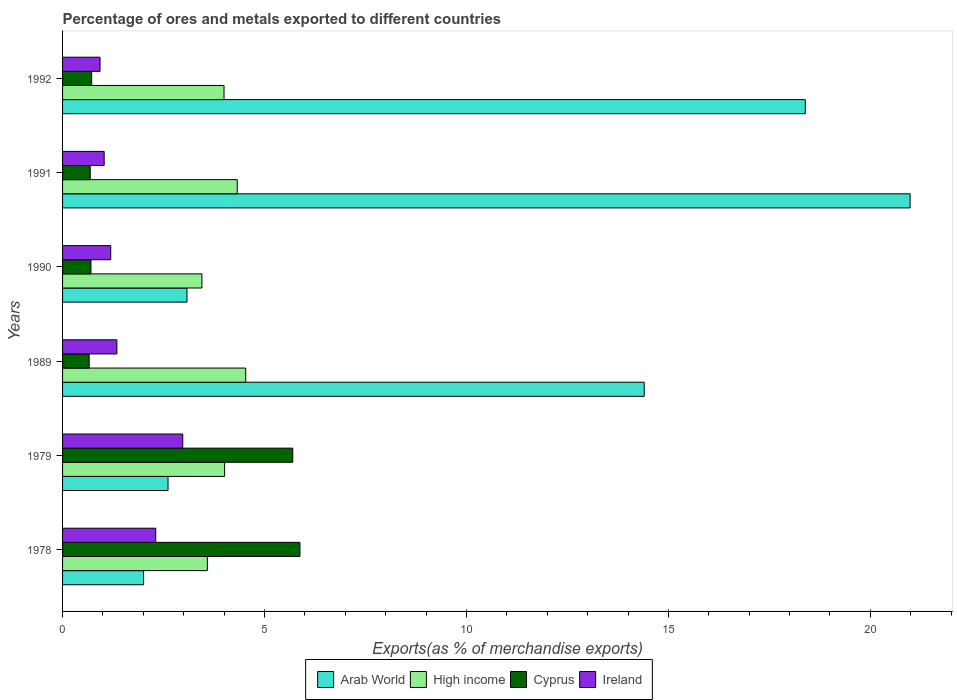How many different coloured bars are there?
Provide a succinct answer. 4. How many groups of bars are there?
Offer a very short reply. 6. Are the number of bars per tick equal to the number of legend labels?
Provide a succinct answer. Yes. In how many cases, is the number of bars for a given year not equal to the number of legend labels?
Offer a terse response. 0. What is the percentage of exports to different countries in Cyprus in 1992?
Provide a succinct answer. 0.72. Across all years, what is the maximum percentage of exports to different countries in High income?
Offer a terse response. 4.54. Across all years, what is the minimum percentage of exports to different countries in Cyprus?
Keep it short and to the point. 0.66. In which year was the percentage of exports to different countries in Cyprus maximum?
Ensure brevity in your answer.  1978. In which year was the percentage of exports to different countries in Arab World minimum?
Make the answer very short. 1978. What is the total percentage of exports to different countries in Ireland in the graph?
Your answer should be very brief. 9.78. What is the difference between the percentage of exports to different countries in Arab World in 1978 and that in 1992?
Keep it short and to the point. -16.38. What is the difference between the percentage of exports to different countries in High income in 1990 and the percentage of exports to different countries in Arab World in 1992?
Make the answer very short. -14.94. What is the average percentage of exports to different countries in High income per year?
Offer a terse response. 3.98. In the year 1979, what is the difference between the percentage of exports to different countries in Ireland and percentage of exports to different countries in Cyprus?
Your answer should be compact. -2.72. What is the ratio of the percentage of exports to different countries in Cyprus in 1979 to that in 1991?
Ensure brevity in your answer.  8.33. Is the percentage of exports to different countries in Ireland in 1979 less than that in 1990?
Your answer should be compact. No. Is the difference between the percentage of exports to different countries in Ireland in 1990 and 1992 greater than the difference between the percentage of exports to different countries in Cyprus in 1990 and 1992?
Your answer should be compact. Yes. What is the difference between the highest and the second highest percentage of exports to different countries in Arab World?
Provide a short and direct response. 2.6. What is the difference between the highest and the lowest percentage of exports to different countries in Arab World?
Give a very brief answer. 18.98. Is the sum of the percentage of exports to different countries in Ireland in 1979 and 1991 greater than the maximum percentage of exports to different countries in Arab World across all years?
Your answer should be very brief. No. What does the 3rd bar from the top in 1992 represents?
Make the answer very short. High income. What does the 4th bar from the bottom in 1992 represents?
Keep it short and to the point. Ireland. Are the values on the major ticks of X-axis written in scientific E-notation?
Offer a terse response. No. How are the legend labels stacked?
Provide a short and direct response. Horizontal. What is the title of the graph?
Keep it short and to the point. Percentage of ores and metals exported to different countries. What is the label or title of the X-axis?
Offer a terse response. Exports(as % of merchandise exports). What is the Exports(as % of merchandise exports) of Arab World in 1978?
Provide a short and direct response. 2.01. What is the Exports(as % of merchandise exports) in High income in 1978?
Offer a very short reply. 3.58. What is the Exports(as % of merchandise exports) of Cyprus in 1978?
Your answer should be compact. 5.88. What is the Exports(as % of merchandise exports) in Ireland in 1978?
Your answer should be very brief. 2.31. What is the Exports(as % of merchandise exports) in Arab World in 1979?
Your answer should be compact. 2.61. What is the Exports(as % of merchandise exports) of High income in 1979?
Give a very brief answer. 4.01. What is the Exports(as % of merchandise exports) in Cyprus in 1979?
Your response must be concise. 5.7. What is the Exports(as % of merchandise exports) of Ireland in 1979?
Make the answer very short. 2.98. What is the Exports(as % of merchandise exports) of Arab World in 1989?
Give a very brief answer. 14.4. What is the Exports(as % of merchandise exports) in High income in 1989?
Keep it short and to the point. 4.54. What is the Exports(as % of merchandise exports) in Cyprus in 1989?
Provide a short and direct response. 0.66. What is the Exports(as % of merchandise exports) in Ireland in 1989?
Your answer should be compact. 1.34. What is the Exports(as % of merchandise exports) in Arab World in 1990?
Make the answer very short. 3.08. What is the Exports(as % of merchandise exports) in High income in 1990?
Ensure brevity in your answer.  3.45. What is the Exports(as % of merchandise exports) of Cyprus in 1990?
Offer a very short reply. 0.7. What is the Exports(as % of merchandise exports) in Ireland in 1990?
Offer a very short reply. 1.19. What is the Exports(as % of merchandise exports) in Arab World in 1991?
Ensure brevity in your answer.  20.98. What is the Exports(as % of merchandise exports) in High income in 1991?
Ensure brevity in your answer.  4.32. What is the Exports(as % of merchandise exports) of Cyprus in 1991?
Keep it short and to the point. 0.68. What is the Exports(as % of merchandise exports) of Ireland in 1991?
Provide a short and direct response. 1.03. What is the Exports(as % of merchandise exports) in Arab World in 1992?
Give a very brief answer. 18.39. What is the Exports(as % of merchandise exports) of High income in 1992?
Your response must be concise. 4. What is the Exports(as % of merchandise exports) in Cyprus in 1992?
Offer a terse response. 0.72. What is the Exports(as % of merchandise exports) in Ireland in 1992?
Give a very brief answer. 0.93. Across all years, what is the maximum Exports(as % of merchandise exports) in Arab World?
Your response must be concise. 20.98. Across all years, what is the maximum Exports(as % of merchandise exports) in High income?
Keep it short and to the point. 4.54. Across all years, what is the maximum Exports(as % of merchandise exports) of Cyprus?
Your answer should be very brief. 5.88. Across all years, what is the maximum Exports(as % of merchandise exports) in Ireland?
Offer a very short reply. 2.98. Across all years, what is the minimum Exports(as % of merchandise exports) of Arab World?
Give a very brief answer. 2.01. Across all years, what is the minimum Exports(as % of merchandise exports) in High income?
Your answer should be compact. 3.45. Across all years, what is the minimum Exports(as % of merchandise exports) in Cyprus?
Ensure brevity in your answer.  0.66. Across all years, what is the minimum Exports(as % of merchandise exports) of Ireland?
Give a very brief answer. 0.93. What is the total Exports(as % of merchandise exports) in Arab World in the graph?
Provide a succinct answer. 61.47. What is the total Exports(as % of merchandise exports) of High income in the graph?
Offer a very short reply. 23.91. What is the total Exports(as % of merchandise exports) of Cyprus in the graph?
Provide a succinct answer. 14.34. What is the total Exports(as % of merchandise exports) in Ireland in the graph?
Offer a very short reply. 9.78. What is the difference between the Exports(as % of merchandise exports) of Arab World in 1978 and that in 1979?
Keep it short and to the point. -0.6. What is the difference between the Exports(as % of merchandise exports) of High income in 1978 and that in 1979?
Offer a terse response. -0.43. What is the difference between the Exports(as % of merchandise exports) in Cyprus in 1978 and that in 1979?
Offer a terse response. 0.18. What is the difference between the Exports(as % of merchandise exports) in Ireland in 1978 and that in 1979?
Your answer should be compact. -0.67. What is the difference between the Exports(as % of merchandise exports) of Arab World in 1978 and that in 1989?
Provide a short and direct response. -12.39. What is the difference between the Exports(as % of merchandise exports) of High income in 1978 and that in 1989?
Your response must be concise. -0.95. What is the difference between the Exports(as % of merchandise exports) in Cyprus in 1978 and that in 1989?
Offer a very short reply. 5.22. What is the difference between the Exports(as % of merchandise exports) in Ireland in 1978 and that in 1989?
Your answer should be very brief. 0.96. What is the difference between the Exports(as % of merchandise exports) of Arab World in 1978 and that in 1990?
Ensure brevity in your answer.  -1.07. What is the difference between the Exports(as % of merchandise exports) in High income in 1978 and that in 1990?
Your answer should be very brief. 0.13. What is the difference between the Exports(as % of merchandise exports) in Cyprus in 1978 and that in 1990?
Keep it short and to the point. 5.17. What is the difference between the Exports(as % of merchandise exports) in Ireland in 1978 and that in 1990?
Your answer should be compact. 1.11. What is the difference between the Exports(as % of merchandise exports) in Arab World in 1978 and that in 1991?
Your answer should be very brief. -18.98. What is the difference between the Exports(as % of merchandise exports) of High income in 1978 and that in 1991?
Your answer should be very brief. -0.74. What is the difference between the Exports(as % of merchandise exports) in Cyprus in 1978 and that in 1991?
Ensure brevity in your answer.  5.19. What is the difference between the Exports(as % of merchandise exports) in Ireland in 1978 and that in 1991?
Offer a very short reply. 1.28. What is the difference between the Exports(as % of merchandise exports) in Arab World in 1978 and that in 1992?
Provide a succinct answer. -16.38. What is the difference between the Exports(as % of merchandise exports) of High income in 1978 and that in 1992?
Give a very brief answer. -0.41. What is the difference between the Exports(as % of merchandise exports) in Cyprus in 1978 and that in 1992?
Offer a terse response. 5.16. What is the difference between the Exports(as % of merchandise exports) in Ireland in 1978 and that in 1992?
Offer a terse response. 1.38. What is the difference between the Exports(as % of merchandise exports) in Arab World in 1979 and that in 1989?
Make the answer very short. -11.79. What is the difference between the Exports(as % of merchandise exports) in High income in 1979 and that in 1989?
Your answer should be compact. -0.52. What is the difference between the Exports(as % of merchandise exports) of Cyprus in 1979 and that in 1989?
Your answer should be compact. 5.04. What is the difference between the Exports(as % of merchandise exports) of Ireland in 1979 and that in 1989?
Offer a terse response. 1.63. What is the difference between the Exports(as % of merchandise exports) in Arab World in 1979 and that in 1990?
Provide a short and direct response. -0.47. What is the difference between the Exports(as % of merchandise exports) in High income in 1979 and that in 1990?
Offer a very short reply. 0.56. What is the difference between the Exports(as % of merchandise exports) of Cyprus in 1979 and that in 1990?
Provide a succinct answer. 5. What is the difference between the Exports(as % of merchandise exports) of Ireland in 1979 and that in 1990?
Your response must be concise. 1.78. What is the difference between the Exports(as % of merchandise exports) in Arab World in 1979 and that in 1991?
Your answer should be very brief. -18.37. What is the difference between the Exports(as % of merchandise exports) in High income in 1979 and that in 1991?
Keep it short and to the point. -0.31. What is the difference between the Exports(as % of merchandise exports) of Cyprus in 1979 and that in 1991?
Provide a succinct answer. 5.01. What is the difference between the Exports(as % of merchandise exports) of Ireland in 1979 and that in 1991?
Keep it short and to the point. 1.95. What is the difference between the Exports(as % of merchandise exports) of Arab World in 1979 and that in 1992?
Your response must be concise. -15.78. What is the difference between the Exports(as % of merchandise exports) of High income in 1979 and that in 1992?
Give a very brief answer. 0.01. What is the difference between the Exports(as % of merchandise exports) in Cyprus in 1979 and that in 1992?
Provide a succinct answer. 4.98. What is the difference between the Exports(as % of merchandise exports) of Ireland in 1979 and that in 1992?
Keep it short and to the point. 2.05. What is the difference between the Exports(as % of merchandise exports) in Arab World in 1989 and that in 1990?
Keep it short and to the point. 11.32. What is the difference between the Exports(as % of merchandise exports) of High income in 1989 and that in 1990?
Your answer should be very brief. 1.08. What is the difference between the Exports(as % of merchandise exports) in Cyprus in 1989 and that in 1990?
Offer a very short reply. -0.04. What is the difference between the Exports(as % of merchandise exports) of Ireland in 1989 and that in 1990?
Make the answer very short. 0.15. What is the difference between the Exports(as % of merchandise exports) of Arab World in 1989 and that in 1991?
Provide a short and direct response. -6.58. What is the difference between the Exports(as % of merchandise exports) in High income in 1989 and that in 1991?
Provide a short and direct response. 0.21. What is the difference between the Exports(as % of merchandise exports) of Cyprus in 1989 and that in 1991?
Keep it short and to the point. -0.03. What is the difference between the Exports(as % of merchandise exports) of Ireland in 1989 and that in 1991?
Give a very brief answer. 0.31. What is the difference between the Exports(as % of merchandise exports) in Arab World in 1989 and that in 1992?
Keep it short and to the point. -3.99. What is the difference between the Exports(as % of merchandise exports) in High income in 1989 and that in 1992?
Your answer should be compact. 0.54. What is the difference between the Exports(as % of merchandise exports) of Cyprus in 1989 and that in 1992?
Give a very brief answer. -0.06. What is the difference between the Exports(as % of merchandise exports) of Ireland in 1989 and that in 1992?
Provide a succinct answer. 0.42. What is the difference between the Exports(as % of merchandise exports) in Arab World in 1990 and that in 1991?
Your response must be concise. -17.9. What is the difference between the Exports(as % of merchandise exports) of High income in 1990 and that in 1991?
Your response must be concise. -0.87. What is the difference between the Exports(as % of merchandise exports) of Cyprus in 1990 and that in 1991?
Your answer should be compact. 0.02. What is the difference between the Exports(as % of merchandise exports) in Ireland in 1990 and that in 1991?
Make the answer very short. 0.16. What is the difference between the Exports(as % of merchandise exports) in Arab World in 1990 and that in 1992?
Provide a succinct answer. -15.31. What is the difference between the Exports(as % of merchandise exports) in High income in 1990 and that in 1992?
Ensure brevity in your answer.  -0.55. What is the difference between the Exports(as % of merchandise exports) of Cyprus in 1990 and that in 1992?
Ensure brevity in your answer.  -0.02. What is the difference between the Exports(as % of merchandise exports) of Ireland in 1990 and that in 1992?
Offer a terse response. 0.26. What is the difference between the Exports(as % of merchandise exports) of Arab World in 1991 and that in 1992?
Keep it short and to the point. 2.6. What is the difference between the Exports(as % of merchandise exports) of High income in 1991 and that in 1992?
Your answer should be very brief. 0.33. What is the difference between the Exports(as % of merchandise exports) in Cyprus in 1991 and that in 1992?
Make the answer very short. -0.04. What is the difference between the Exports(as % of merchandise exports) in Ireland in 1991 and that in 1992?
Ensure brevity in your answer.  0.1. What is the difference between the Exports(as % of merchandise exports) of Arab World in 1978 and the Exports(as % of merchandise exports) of High income in 1979?
Ensure brevity in your answer.  -2.01. What is the difference between the Exports(as % of merchandise exports) in Arab World in 1978 and the Exports(as % of merchandise exports) in Cyprus in 1979?
Your answer should be compact. -3.69. What is the difference between the Exports(as % of merchandise exports) in Arab World in 1978 and the Exports(as % of merchandise exports) in Ireland in 1979?
Ensure brevity in your answer.  -0.97. What is the difference between the Exports(as % of merchandise exports) in High income in 1978 and the Exports(as % of merchandise exports) in Cyprus in 1979?
Make the answer very short. -2.11. What is the difference between the Exports(as % of merchandise exports) in High income in 1978 and the Exports(as % of merchandise exports) in Ireland in 1979?
Provide a succinct answer. 0.61. What is the difference between the Exports(as % of merchandise exports) of Cyprus in 1978 and the Exports(as % of merchandise exports) of Ireland in 1979?
Offer a terse response. 2.9. What is the difference between the Exports(as % of merchandise exports) of Arab World in 1978 and the Exports(as % of merchandise exports) of High income in 1989?
Your response must be concise. -2.53. What is the difference between the Exports(as % of merchandise exports) of Arab World in 1978 and the Exports(as % of merchandise exports) of Cyprus in 1989?
Your answer should be very brief. 1.35. What is the difference between the Exports(as % of merchandise exports) in Arab World in 1978 and the Exports(as % of merchandise exports) in Ireland in 1989?
Your response must be concise. 0.66. What is the difference between the Exports(as % of merchandise exports) of High income in 1978 and the Exports(as % of merchandise exports) of Cyprus in 1989?
Provide a short and direct response. 2.93. What is the difference between the Exports(as % of merchandise exports) in High income in 1978 and the Exports(as % of merchandise exports) in Ireland in 1989?
Make the answer very short. 2.24. What is the difference between the Exports(as % of merchandise exports) in Cyprus in 1978 and the Exports(as % of merchandise exports) in Ireland in 1989?
Give a very brief answer. 4.53. What is the difference between the Exports(as % of merchandise exports) of Arab World in 1978 and the Exports(as % of merchandise exports) of High income in 1990?
Ensure brevity in your answer.  -1.44. What is the difference between the Exports(as % of merchandise exports) of Arab World in 1978 and the Exports(as % of merchandise exports) of Cyprus in 1990?
Keep it short and to the point. 1.3. What is the difference between the Exports(as % of merchandise exports) of Arab World in 1978 and the Exports(as % of merchandise exports) of Ireland in 1990?
Your response must be concise. 0.81. What is the difference between the Exports(as % of merchandise exports) in High income in 1978 and the Exports(as % of merchandise exports) in Cyprus in 1990?
Give a very brief answer. 2.88. What is the difference between the Exports(as % of merchandise exports) in High income in 1978 and the Exports(as % of merchandise exports) in Ireland in 1990?
Give a very brief answer. 2.39. What is the difference between the Exports(as % of merchandise exports) in Cyprus in 1978 and the Exports(as % of merchandise exports) in Ireland in 1990?
Your answer should be compact. 4.68. What is the difference between the Exports(as % of merchandise exports) in Arab World in 1978 and the Exports(as % of merchandise exports) in High income in 1991?
Give a very brief answer. -2.32. What is the difference between the Exports(as % of merchandise exports) of Arab World in 1978 and the Exports(as % of merchandise exports) of Cyprus in 1991?
Your response must be concise. 1.32. What is the difference between the Exports(as % of merchandise exports) of Arab World in 1978 and the Exports(as % of merchandise exports) of Ireland in 1991?
Offer a very short reply. 0.98. What is the difference between the Exports(as % of merchandise exports) of High income in 1978 and the Exports(as % of merchandise exports) of Cyprus in 1991?
Keep it short and to the point. 2.9. What is the difference between the Exports(as % of merchandise exports) in High income in 1978 and the Exports(as % of merchandise exports) in Ireland in 1991?
Your response must be concise. 2.56. What is the difference between the Exports(as % of merchandise exports) of Cyprus in 1978 and the Exports(as % of merchandise exports) of Ireland in 1991?
Keep it short and to the point. 4.85. What is the difference between the Exports(as % of merchandise exports) of Arab World in 1978 and the Exports(as % of merchandise exports) of High income in 1992?
Provide a succinct answer. -1.99. What is the difference between the Exports(as % of merchandise exports) of Arab World in 1978 and the Exports(as % of merchandise exports) of Cyprus in 1992?
Your response must be concise. 1.29. What is the difference between the Exports(as % of merchandise exports) of Arab World in 1978 and the Exports(as % of merchandise exports) of Ireland in 1992?
Make the answer very short. 1.08. What is the difference between the Exports(as % of merchandise exports) in High income in 1978 and the Exports(as % of merchandise exports) in Cyprus in 1992?
Provide a succinct answer. 2.86. What is the difference between the Exports(as % of merchandise exports) in High income in 1978 and the Exports(as % of merchandise exports) in Ireland in 1992?
Provide a succinct answer. 2.66. What is the difference between the Exports(as % of merchandise exports) in Cyprus in 1978 and the Exports(as % of merchandise exports) in Ireland in 1992?
Offer a very short reply. 4.95. What is the difference between the Exports(as % of merchandise exports) of Arab World in 1979 and the Exports(as % of merchandise exports) of High income in 1989?
Ensure brevity in your answer.  -1.92. What is the difference between the Exports(as % of merchandise exports) in Arab World in 1979 and the Exports(as % of merchandise exports) in Cyprus in 1989?
Keep it short and to the point. 1.95. What is the difference between the Exports(as % of merchandise exports) of Arab World in 1979 and the Exports(as % of merchandise exports) of Ireland in 1989?
Your answer should be very brief. 1.27. What is the difference between the Exports(as % of merchandise exports) in High income in 1979 and the Exports(as % of merchandise exports) in Cyprus in 1989?
Give a very brief answer. 3.35. What is the difference between the Exports(as % of merchandise exports) of High income in 1979 and the Exports(as % of merchandise exports) of Ireland in 1989?
Provide a succinct answer. 2.67. What is the difference between the Exports(as % of merchandise exports) of Cyprus in 1979 and the Exports(as % of merchandise exports) of Ireland in 1989?
Provide a short and direct response. 4.35. What is the difference between the Exports(as % of merchandise exports) of Arab World in 1979 and the Exports(as % of merchandise exports) of High income in 1990?
Ensure brevity in your answer.  -0.84. What is the difference between the Exports(as % of merchandise exports) of Arab World in 1979 and the Exports(as % of merchandise exports) of Cyprus in 1990?
Provide a short and direct response. 1.91. What is the difference between the Exports(as % of merchandise exports) of Arab World in 1979 and the Exports(as % of merchandise exports) of Ireland in 1990?
Your answer should be very brief. 1.42. What is the difference between the Exports(as % of merchandise exports) in High income in 1979 and the Exports(as % of merchandise exports) in Cyprus in 1990?
Give a very brief answer. 3.31. What is the difference between the Exports(as % of merchandise exports) in High income in 1979 and the Exports(as % of merchandise exports) in Ireland in 1990?
Give a very brief answer. 2.82. What is the difference between the Exports(as % of merchandise exports) in Cyprus in 1979 and the Exports(as % of merchandise exports) in Ireland in 1990?
Your answer should be very brief. 4.51. What is the difference between the Exports(as % of merchandise exports) in Arab World in 1979 and the Exports(as % of merchandise exports) in High income in 1991?
Your response must be concise. -1.71. What is the difference between the Exports(as % of merchandise exports) of Arab World in 1979 and the Exports(as % of merchandise exports) of Cyprus in 1991?
Your response must be concise. 1.93. What is the difference between the Exports(as % of merchandise exports) of Arab World in 1979 and the Exports(as % of merchandise exports) of Ireland in 1991?
Your answer should be very brief. 1.58. What is the difference between the Exports(as % of merchandise exports) in High income in 1979 and the Exports(as % of merchandise exports) in Cyprus in 1991?
Provide a short and direct response. 3.33. What is the difference between the Exports(as % of merchandise exports) of High income in 1979 and the Exports(as % of merchandise exports) of Ireland in 1991?
Offer a terse response. 2.98. What is the difference between the Exports(as % of merchandise exports) of Cyprus in 1979 and the Exports(as % of merchandise exports) of Ireland in 1991?
Give a very brief answer. 4.67. What is the difference between the Exports(as % of merchandise exports) of Arab World in 1979 and the Exports(as % of merchandise exports) of High income in 1992?
Offer a terse response. -1.39. What is the difference between the Exports(as % of merchandise exports) in Arab World in 1979 and the Exports(as % of merchandise exports) in Cyprus in 1992?
Make the answer very short. 1.89. What is the difference between the Exports(as % of merchandise exports) in Arab World in 1979 and the Exports(as % of merchandise exports) in Ireland in 1992?
Keep it short and to the point. 1.68. What is the difference between the Exports(as % of merchandise exports) of High income in 1979 and the Exports(as % of merchandise exports) of Cyprus in 1992?
Give a very brief answer. 3.29. What is the difference between the Exports(as % of merchandise exports) in High income in 1979 and the Exports(as % of merchandise exports) in Ireland in 1992?
Your response must be concise. 3.08. What is the difference between the Exports(as % of merchandise exports) in Cyprus in 1979 and the Exports(as % of merchandise exports) in Ireland in 1992?
Keep it short and to the point. 4.77. What is the difference between the Exports(as % of merchandise exports) of Arab World in 1989 and the Exports(as % of merchandise exports) of High income in 1990?
Give a very brief answer. 10.95. What is the difference between the Exports(as % of merchandise exports) in Arab World in 1989 and the Exports(as % of merchandise exports) in Cyprus in 1990?
Give a very brief answer. 13.7. What is the difference between the Exports(as % of merchandise exports) of Arab World in 1989 and the Exports(as % of merchandise exports) of Ireland in 1990?
Give a very brief answer. 13.21. What is the difference between the Exports(as % of merchandise exports) of High income in 1989 and the Exports(as % of merchandise exports) of Cyprus in 1990?
Provide a succinct answer. 3.83. What is the difference between the Exports(as % of merchandise exports) of High income in 1989 and the Exports(as % of merchandise exports) of Ireland in 1990?
Provide a succinct answer. 3.34. What is the difference between the Exports(as % of merchandise exports) of Cyprus in 1989 and the Exports(as % of merchandise exports) of Ireland in 1990?
Provide a succinct answer. -0.53. What is the difference between the Exports(as % of merchandise exports) of Arab World in 1989 and the Exports(as % of merchandise exports) of High income in 1991?
Provide a short and direct response. 10.08. What is the difference between the Exports(as % of merchandise exports) in Arab World in 1989 and the Exports(as % of merchandise exports) in Cyprus in 1991?
Your answer should be compact. 13.72. What is the difference between the Exports(as % of merchandise exports) of Arab World in 1989 and the Exports(as % of merchandise exports) of Ireland in 1991?
Your answer should be very brief. 13.37. What is the difference between the Exports(as % of merchandise exports) in High income in 1989 and the Exports(as % of merchandise exports) in Cyprus in 1991?
Offer a terse response. 3.85. What is the difference between the Exports(as % of merchandise exports) of High income in 1989 and the Exports(as % of merchandise exports) of Ireland in 1991?
Provide a succinct answer. 3.51. What is the difference between the Exports(as % of merchandise exports) in Cyprus in 1989 and the Exports(as % of merchandise exports) in Ireland in 1991?
Your answer should be very brief. -0.37. What is the difference between the Exports(as % of merchandise exports) of Arab World in 1989 and the Exports(as % of merchandise exports) of High income in 1992?
Provide a succinct answer. 10.4. What is the difference between the Exports(as % of merchandise exports) of Arab World in 1989 and the Exports(as % of merchandise exports) of Cyprus in 1992?
Give a very brief answer. 13.68. What is the difference between the Exports(as % of merchandise exports) in Arab World in 1989 and the Exports(as % of merchandise exports) in Ireland in 1992?
Make the answer very short. 13.47. What is the difference between the Exports(as % of merchandise exports) in High income in 1989 and the Exports(as % of merchandise exports) in Cyprus in 1992?
Give a very brief answer. 3.81. What is the difference between the Exports(as % of merchandise exports) of High income in 1989 and the Exports(as % of merchandise exports) of Ireland in 1992?
Make the answer very short. 3.61. What is the difference between the Exports(as % of merchandise exports) in Cyprus in 1989 and the Exports(as % of merchandise exports) in Ireland in 1992?
Your response must be concise. -0.27. What is the difference between the Exports(as % of merchandise exports) of Arab World in 1990 and the Exports(as % of merchandise exports) of High income in 1991?
Your response must be concise. -1.24. What is the difference between the Exports(as % of merchandise exports) of Arab World in 1990 and the Exports(as % of merchandise exports) of Cyprus in 1991?
Ensure brevity in your answer.  2.4. What is the difference between the Exports(as % of merchandise exports) of Arab World in 1990 and the Exports(as % of merchandise exports) of Ireland in 1991?
Offer a very short reply. 2.05. What is the difference between the Exports(as % of merchandise exports) in High income in 1990 and the Exports(as % of merchandise exports) in Cyprus in 1991?
Your answer should be very brief. 2.77. What is the difference between the Exports(as % of merchandise exports) of High income in 1990 and the Exports(as % of merchandise exports) of Ireland in 1991?
Give a very brief answer. 2.42. What is the difference between the Exports(as % of merchandise exports) of Cyprus in 1990 and the Exports(as % of merchandise exports) of Ireland in 1991?
Provide a short and direct response. -0.33. What is the difference between the Exports(as % of merchandise exports) in Arab World in 1990 and the Exports(as % of merchandise exports) in High income in 1992?
Provide a succinct answer. -0.92. What is the difference between the Exports(as % of merchandise exports) in Arab World in 1990 and the Exports(as % of merchandise exports) in Cyprus in 1992?
Give a very brief answer. 2.36. What is the difference between the Exports(as % of merchandise exports) in Arab World in 1990 and the Exports(as % of merchandise exports) in Ireland in 1992?
Make the answer very short. 2.15. What is the difference between the Exports(as % of merchandise exports) in High income in 1990 and the Exports(as % of merchandise exports) in Cyprus in 1992?
Give a very brief answer. 2.73. What is the difference between the Exports(as % of merchandise exports) in High income in 1990 and the Exports(as % of merchandise exports) in Ireland in 1992?
Provide a short and direct response. 2.52. What is the difference between the Exports(as % of merchandise exports) in Cyprus in 1990 and the Exports(as % of merchandise exports) in Ireland in 1992?
Your answer should be compact. -0.22. What is the difference between the Exports(as % of merchandise exports) of Arab World in 1991 and the Exports(as % of merchandise exports) of High income in 1992?
Offer a terse response. 16.99. What is the difference between the Exports(as % of merchandise exports) of Arab World in 1991 and the Exports(as % of merchandise exports) of Cyprus in 1992?
Provide a succinct answer. 20.26. What is the difference between the Exports(as % of merchandise exports) in Arab World in 1991 and the Exports(as % of merchandise exports) in Ireland in 1992?
Offer a terse response. 20.06. What is the difference between the Exports(as % of merchandise exports) in High income in 1991 and the Exports(as % of merchandise exports) in Cyprus in 1992?
Ensure brevity in your answer.  3.6. What is the difference between the Exports(as % of merchandise exports) of High income in 1991 and the Exports(as % of merchandise exports) of Ireland in 1992?
Your response must be concise. 3.4. What is the difference between the Exports(as % of merchandise exports) of Cyprus in 1991 and the Exports(as % of merchandise exports) of Ireland in 1992?
Give a very brief answer. -0.24. What is the average Exports(as % of merchandise exports) in Arab World per year?
Keep it short and to the point. 10.25. What is the average Exports(as % of merchandise exports) of High income per year?
Give a very brief answer. 3.98. What is the average Exports(as % of merchandise exports) of Cyprus per year?
Keep it short and to the point. 2.39. What is the average Exports(as % of merchandise exports) of Ireland per year?
Your answer should be compact. 1.63. In the year 1978, what is the difference between the Exports(as % of merchandise exports) in Arab World and Exports(as % of merchandise exports) in High income?
Provide a succinct answer. -1.58. In the year 1978, what is the difference between the Exports(as % of merchandise exports) of Arab World and Exports(as % of merchandise exports) of Cyprus?
Provide a succinct answer. -3.87. In the year 1978, what is the difference between the Exports(as % of merchandise exports) in Arab World and Exports(as % of merchandise exports) in Ireland?
Offer a terse response. -0.3. In the year 1978, what is the difference between the Exports(as % of merchandise exports) in High income and Exports(as % of merchandise exports) in Cyprus?
Your response must be concise. -2.29. In the year 1978, what is the difference between the Exports(as % of merchandise exports) in High income and Exports(as % of merchandise exports) in Ireland?
Your answer should be very brief. 1.28. In the year 1978, what is the difference between the Exports(as % of merchandise exports) in Cyprus and Exports(as % of merchandise exports) in Ireland?
Make the answer very short. 3.57. In the year 1979, what is the difference between the Exports(as % of merchandise exports) of Arab World and Exports(as % of merchandise exports) of High income?
Give a very brief answer. -1.4. In the year 1979, what is the difference between the Exports(as % of merchandise exports) in Arab World and Exports(as % of merchandise exports) in Cyprus?
Ensure brevity in your answer.  -3.09. In the year 1979, what is the difference between the Exports(as % of merchandise exports) in Arab World and Exports(as % of merchandise exports) in Ireland?
Give a very brief answer. -0.36. In the year 1979, what is the difference between the Exports(as % of merchandise exports) of High income and Exports(as % of merchandise exports) of Cyprus?
Ensure brevity in your answer.  -1.69. In the year 1979, what is the difference between the Exports(as % of merchandise exports) of High income and Exports(as % of merchandise exports) of Ireland?
Ensure brevity in your answer.  1.04. In the year 1979, what is the difference between the Exports(as % of merchandise exports) in Cyprus and Exports(as % of merchandise exports) in Ireland?
Your answer should be very brief. 2.72. In the year 1989, what is the difference between the Exports(as % of merchandise exports) in Arab World and Exports(as % of merchandise exports) in High income?
Provide a short and direct response. 9.87. In the year 1989, what is the difference between the Exports(as % of merchandise exports) of Arab World and Exports(as % of merchandise exports) of Cyprus?
Provide a short and direct response. 13.74. In the year 1989, what is the difference between the Exports(as % of merchandise exports) of Arab World and Exports(as % of merchandise exports) of Ireland?
Ensure brevity in your answer.  13.06. In the year 1989, what is the difference between the Exports(as % of merchandise exports) of High income and Exports(as % of merchandise exports) of Cyprus?
Give a very brief answer. 3.88. In the year 1989, what is the difference between the Exports(as % of merchandise exports) of High income and Exports(as % of merchandise exports) of Ireland?
Keep it short and to the point. 3.19. In the year 1989, what is the difference between the Exports(as % of merchandise exports) of Cyprus and Exports(as % of merchandise exports) of Ireland?
Your answer should be compact. -0.69. In the year 1990, what is the difference between the Exports(as % of merchandise exports) in Arab World and Exports(as % of merchandise exports) in High income?
Provide a short and direct response. -0.37. In the year 1990, what is the difference between the Exports(as % of merchandise exports) in Arab World and Exports(as % of merchandise exports) in Cyprus?
Your answer should be very brief. 2.38. In the year 1990, what is the difference between the Exports(as % of merchandise exports) of Arab World and Exports(as % of merchandise exports) of Ireland?
Your answer should be very brief. 1.89. In the year 1990, what is the difference between the Exports(as % of merchandise exports) of High income and Exports(as % of merchandise exports) of Cyprus?
Your answer should be very brief. 2.75. In the year 1990, what is the difference between the Exports(as % of merchandise exports) of High income and Exports(as % of merchandise exports) of Ireland?
Offer a terse response. 2.26. In the year 1990, what is the difference between the Exports(as % of merchandise exports) in Cyprus and Exports(as % of merchandise exports) in Ireland?
Offer a terse response. -0.49. In the year 1991, what is the difference between the Exports(as % of merchandise exports) in Arab World and Exports(as % of merchandise exports) in High income?
Your answer should be very brief. 16.66. In the year 1991, what is the difference between the Exports(as % of merchandise exports) of Arab World and Exports(as % of merchandise exports) of Cyprus?
Your response must be concise. 20.3. In the year 1991, what is the difference between the Exports(as % of merchandise exports) in Arab World and Exports(as % of merchandise exports) in Ireland?
Give a very brief answer. 19.95. In the year 1991, what is the difference between the Exports(as % of merchandise exports) of High income and Exports(as % of merchandise exports) of Cyprus?
Keep it short and to the point. 3.64. In the year 1991, what is the difference between the Exports(as % of merchandise exports) of High income and Exports(as % of merchandise exports) of Ireland?
Provide a short and direct response. 3.29. In the year 1991, what is the difference between the Exports(as % of merchandise exports) of Cyprus and Exports(as % of merchandise exports) of Ireland?
Your answer should be very brief. -0.35. In the year 1992, what is the difference between the Exports(as % of merchandise exports) in Arab World and Exports(as % of merchandise exports) in High income?
Your response must be concise. 14.39. In the year 1992, what is the difference between the Exports(as % of merchandise exports) of Arab World and Exports(as % of merchandise exports) of Cyprus?
Give a very brief answer. 17.67. In the year 1992, what is the difference between the Exports(as % of merchandise exports) in Arab World and Exports(as % of merchandise exports) in Ireland?
Provide a succinct answer. 17.46. In the year 1992, what is the difference between the Exports(as % of merchandise exports) in High income and Exports(as % of merchandise exports) in Cyprus?
Your answer should be compact. 3.28. In the year 1992, what is the difference between the Exports(as % of merchandise exports) of High income and Exports(as % of merchandise exports) of Ireland?
Your response must be concise. 3.07. In the year 1992, what is the difference between the Exports(as % of merchandise exports) in Cyprus and Exports(as % of merchandise exports) in Ireland?
Provide a short and direct response. -0.21. What is the ratio of the Exports(as % of merchandise exports) of Arab World in 1978 to that in 1979?
Your answer should be very brief. 0.77. What is the ratio of the Exports(as % of merchandise exports) of High income in 1978 to that in 1979?
Provide a short and direct response. 0.89. What is the ratio of the Exports(as % of merchandise exports) in Cyprus in 1978 to that in 1979?
Your response must be concise. 1.03. What is the ratio of the Exports(as % of merchandise exports) of Ireland in 1978 to that in 1979?
Offer a very short reply. 0.78. What is the ratio of the Exports(as % of merchandise exports) in Arab World in 1978 to that in 1989?
Your answer should be very brief. 0.14. What is the ratio of the Exports(as % of merchandise exports) of High income in 1978 to that in 1989?
Provide a short and direct response. 0.79. What is the ratio of the Exports(as % of merchandise exports) of Cyprus in 1978 to that in 1989?
Your response must be concise. 8.93. What is the ratio of the Exports(as % of merchandise exports) of Ireland in 1978 to that in 1989?
Your response must be concise. 1.72. What is the ratio of the Exports(as % of merchandise exports) of Arab World in 1978 to that in 1990?
Your answer should be very brief. 0.65. What is the ratio of the Exports(as % of merchandise exports) of High income in 1978 to that in 1990?
Offer a very short reply. 1.04. What is the ratio of the Exports(as % of merchandise exports) in Cyprus in 1978 to that in 1990?
Your response must be concise. 8.36. What is the ratio of the Exports(as % of merchandise exports) of Ireland in 1978 to that in 1990?
Offer a terse response. 1.93. What is the ratio of the Exports(as % of merchandise exports) in Arab World in 1978 to that in 1991?
Provide a short and direct response. 0.1. What is the ratio of the Exports(as % of merchandise exports) in High income in 1978 to that in 1991?
Make the answer very short. 0.83. What is the ratio of the Exports(as % of merchandise exports) in Cyprus in 1978 to that in 1991?
Keep it short and to the point. 8.59. What is the ratio of the Exports(as % of merchandise exports) of Ireland in 1978 to that in 1991?
Offer a terse response. 2.24. What is the ratio of the Exports(as % of merchandise exports) of Arab World in 1978 to that in 1992?
Ensure brevity in your answer.  0.11. What is the ratio of the Exports(as % of merchandise exports) of High income in 1978 to that in 1992?
Offer a very short reply. 0.9. What is the ratio of the Exports(as % of merchandise exports) in Cyprus in 1978 to that in 1992?
Provide a succinct answer. 8.16. What is the ratio of the Exports(as % of merchandise exports) in Ireland in 1978 to that in 1992?
Give a very brief answer. 2.49. What is the ratio of the Exports(as % of merchandise exports) of Arab World in 1979 to that in 1989?
Your answer should be very brief. 0.18. What is the ratio of the Exports(as % of merchandise exports) in High income in 1979 to that in 1989?
Keep it short and to the point. 0.88. What is the ratio of the Exports(as % of merchandise exports) in Cyprus in 1979 to that in 1989?
Ensure brevity in your answer.  8.66. What is the ratio of the Exports(as % of merchandise exports) of Ireland in 1979 to that in 1989?
Provide a short and direct response. 2.21. What is the ratio of the Exports(as % of merchandise exports) in Arab World in 1979 to that in 1990?
Provide a succinct answer. 0.85. What is the ratio of the Exports(as % of merchandise exports) of High income in 1979 to that in 1990?
Your answer should be very brief. 1.16. What is the ratio of the Exports(as % of merchandise exports) of Cyprus in 1979 to that in 1990?
Provide a short and direct response. 8.11. What is the ratio of the Exports(as % of merchandise exports) in Ireland in 1979 to that in 1990?
Your answer should be very brief. 2.5. What is the ratio of the Exports(as % of merchandise exports) of Arab World in 1979 to that in 1991?
Keep it short and to the point. 0.12. What is the ratio of the Exports(as % of merchandise exports) in High income in 1979 to that in 1991?
Your answer should be very brief. 0.93. What is the ratio of the Exports(as % of merchandise exports) of Cyprus in 1979 to that in 1991?
Provide a short and direct response. 8.33. What is the ratio of the Exports(as % of merchandise exports) in Ireland in 1979 to that in 1991?
Your answer should be very brief. 2.89. What is the ratio of the Exports(as % of merchandise exports) of Arab World in 1979 to that in 1992?
Offer a very short reply. 0.14. What is the ratio of the Exports(as % of merchandise exports) of High income in 1979 to that in 1992?
Provide a succinct answer. 1. What is the ratio of the Exports(as % of merchandise exports) of Cyprus in 1979 to that in 1992?
Your response must be concise. 7.91. What is the ratio of the Exports(as % of merchandise exports) in Ireland in 1979 to that in 1992?
Make the answer very short. 3.21. What is the ratio of the Exports(as % of merchandise exports) in Arab World in 1989 to that in 1990?
Give a very brief answer. 4.67. What is the ratio of the Exports(as % of merchandise exports) of High income in 1989 to that in 1990?
Provide a succinct answer. 1.31. What is the ratio of the Exports(as % of merchandise exports) in Cyprus in 1989 to that in 1990?
Offer a terse response. 0.94. What is the ratio of the Exports(as % of merchandise exports) in Ireland in 1989 to that in 1990?
Give a very brief answer. 1.13. What is the ratio of the Exports(as % of merchandise exports) of Arab World in 1989 to that in 1991?
Your answer should be very brief. 0.69. What is the ratio of the Exports(as % of merchandise exports) of High income in 1989 to that in 1991?
Give a very brief answer. 1.05. What is the ratio of the Exports(as % of merchandise exports) in Cyprus in 1989 to that in 1991?
Make the answer very short. 0.96. What is the ratio of the Exports(as % of merchandise exports) of Ireland in 1989 to that in 1991?
Ensure brevity in your answer.  1.31. What is the ratio of the Exports(as % of merchandise exports) of Arab World in 1989 to that in 1992?
Keep it short and to the point. 0.78. What is the ratio of the Exports(as % of merchandise exports) in High income in 1989 to that in 1992?
Provide a succinct answer. 1.13. What is the ratio of the Exports(as % of merchandise exports) of Cyprus in 1989 to that in 1992?
Give a very brief answer. 0.91. What is the ratio of the Exports(as % of merchandise exports) in Ireland in 1989 to that in 1992?
Keep it short and to the point. 1.45. What is the ratio of the Exports(as % of merchandise exports) in Arab World in 1990 to that in 1991?
Offer a very short reply. 0.15. What is the ratio of the Exports(as % of merchandise exports) in High income in 1990 to that in 1991?
Offer a terse response. 0.8. What is the ratio of the Exports(as % of merchandise exports) in Cyprus in 1990 to that in 1991?
Make the answer very short. 1.03. What is the ratio of the Exports(as % of merchandise exports) of Ireland in 1990 to that in 1991?
Keep it short and to the point. 1.16. What is the ratio of the Exports(as % of merchandise exports) of Arab World in 1990 to that in 1992?
Keep it short and to the point. 0.17. What is the ratio of the Exports(as % of merchandise exports) of High income in 1990 to that in 1992?
Keep it short and to the point. 0.86. What is the ratio of the Exports(as % of merchandise exports) in Cyprus in 1990 to that in 1992?
Give a very brief answer. 0.98. What is the ratio of the Exports(as % of merchandise exports) of Ireland in 1990 to that in 1992?
Your answer should be compact. 1.29. What is the ratio of the Exports(as % of merchandise exports) in Arab World in 1991 to that in 1992?
Make the answer very short. 1.14. What is the ratio of the Exports(as % of merchandise exports) in High income in 1991 to that in 1992?
Provide a short and direct response. 1.08. What is the ratio of the Exports(as % of merchandise exports) in Cyprus in 1991 to that in 1992?
Give a very brief answer. 0.95. What is the ratio of the Exports(as % of merchandise exports) in Ireland in 1991 to that in 1992?
Ensure brevity in your answer.  1.11. What is the difference between the highest and the second highest Exports(as % of merchandise exports) of Arab World?
Offer a terse response. 2.6. What is the difference between the highest and the second highest Exports(as % of merchandise exports) of High income?
Your answer should be very brief. 0.21. What is the difference between the highest and the second highest Exports(as % of merchandise exports) of Cyprus?
Keep it short and to the point. 0.18. What is the difference between the highest and the second highest Exports(as % of merchandise exports) of Ireland?
Your response must be concise. 0.67. What is the difference between the highest and the lowest Exports(as % of merchandise exports) of Arab World?
Ensure brevity in your answer.  18.98. What is the difference between the highest and the lowest Exports(as % of merchandise exports) of High income?
Keep it short and to the point. 1.08. What is the difference between the highest and the lowest Exports(as % of merchandise exports) of Cyprus?
Your answer should be very brief. 5.22. What is the difference between the highest and the lowest Exports(as % of merchandise exports) in Ireland?
Give a very brief answer. 2.05. 